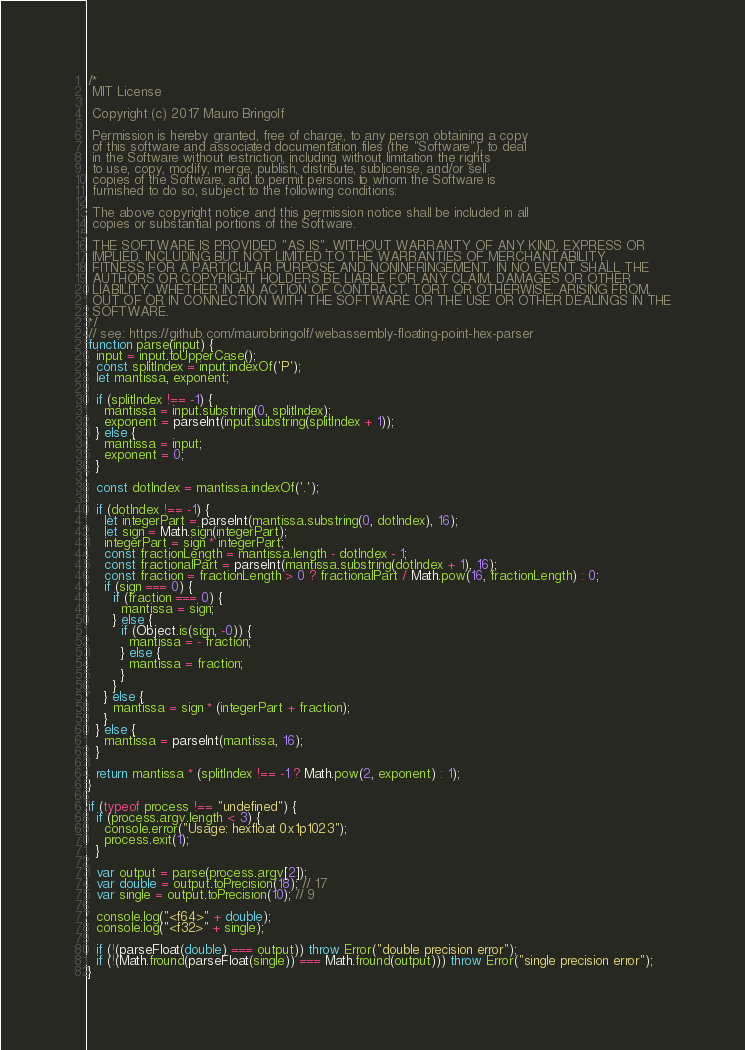<code> <loc_0><loc_0><loc_500><loc_500><_JavaScript_>/*
 MIT License

 Copyright (c) 2017 Mauro Bringolf

 Permission is hereby granted, free of charge, to any person obtaining a copy
 of this software and associated documentation files (the "Software"), to deal
 in the Software without restriction, including without limitation the rights
 to use, copy, modify, merge, publish, distribute, sublicense, and/or sell
 copies of the Software, and to permit persons to whom the Software is
 furnished to do so, subject to the following conditions:

 The above copyright notice and this permission notice shall be included in all
 copies or substantial portions of the Software.

 THE SOFTWARE IS PROVIDED "AS IS", WITHOUT WARRANTY OF ANY KIND, EXPRESS OR
 IMPLIED, INCLUDING BUT NOT LIMITED TO THE WARRANTIES OF MERCHANTABILITY,
 FITNESS FOR A PARTICULAR PURPOSE AND NONINFRINGEMENT. IN NO EVENT SHALL THE
 AUTHORS OR COPYRIGHT HOLDERS BE LIABLE FOR ANY CLAIM, DAMAGES OR OTHER
 LIABILITY, WHETHER IN AN ACTION OF CONTRACT, TORT OR OTHERWISE, ARISING FROM,
 OUT OF OR IN CONNECTION WITH THE SOFTWARE OR THE USE OR OTHER DEALINGS IN THE
 SOFTWARE.
*/
// see: https://github.com/maurobringolf/webassembly-floating-point-hex-parser
function parse(input) {
  input = input.toUpperCase();
  const splitIndex = input.indexOf('P');
  let mantissa, exponent;

  if (splitIndex !== -1) {
    mantissa = input.substring(0, splitIndex);
    exponent = parseInt(input.substring(splitIndex + 1));
  } else {
    mantissa = input;
    exponent = 0;
  }

  const dotIndex = mantissa.indexOf('.');

  if (dotIndex !== -1) {
    let integerPart = parseInt(mantissa.substring(0, dotIndex), 16);
    let sign = Math.sign(integerPart);
    integerPart = sign * integerPart;
    const fractionLength = mantissa.length - dotIndex - 1;
    const fractionalPart = parseInt(mantissa.substring(dotIndex + 1), 16);
    const fraction = fractionLength > 0 ? fractionalPart / Math.pow(16, fractionLength) : 0;
    if (sign === 0) {
      if (fraction === 0) {
        mantissa = sign;
      } else {
        if (Object.is(sign, -0)) {
          mantissa = - fraction;
        } else {
          mantissa = fraction;
        }
      }
    } else {
      mantissa = sign * (integerPart + fraction);
    }
  } else {
    mantissa = parseInt(mantissa, 16);
  }

  return mantissa * (splitIndex !== -1 ? Math.pow(2, exponent) : 1);
}

if (typeof process !== "undefined") {
  if (process.argv.length < 3) {
    console.error("Usage: hexfloat 0x1p1023");
    process.exit(1);
  }

  var output = parse(process.argv[2]);
  var double = output.toPrecision(18); // 17
  var single = output.toPrecision(10); // 9

  console.log("<f64>" + double);
  console.log("<f32>" + single);

  if (!(parseFloat(double) === output)) throw Error("double precision error");
  if (!(Math.fround(parseFloat(single)) === Math.fround(output))) throw Error("single precision error");
}
</code> 